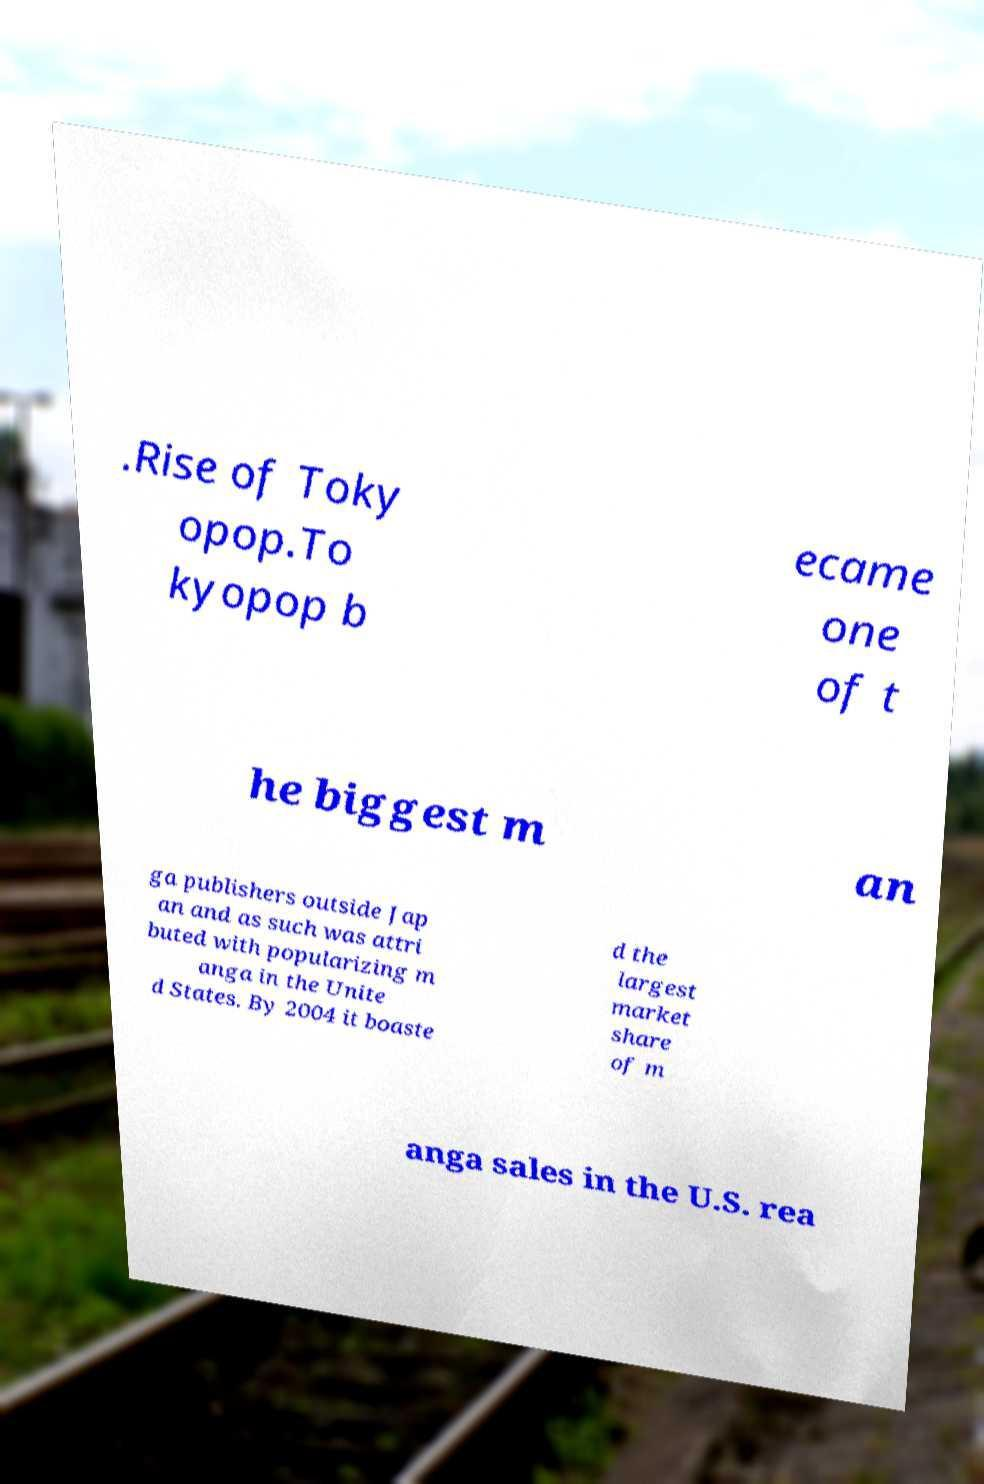I need the written content from this picture converted into text. Can you do that? .Rise of Toky opop.To kyopop b ecame one of t he biggest m an ga publishers outside Jap an and as such was attri buted with popularizing m anga in the Unite d States. By 2004 it boaste d the largest market share of m anga sales in the U.S. rea 